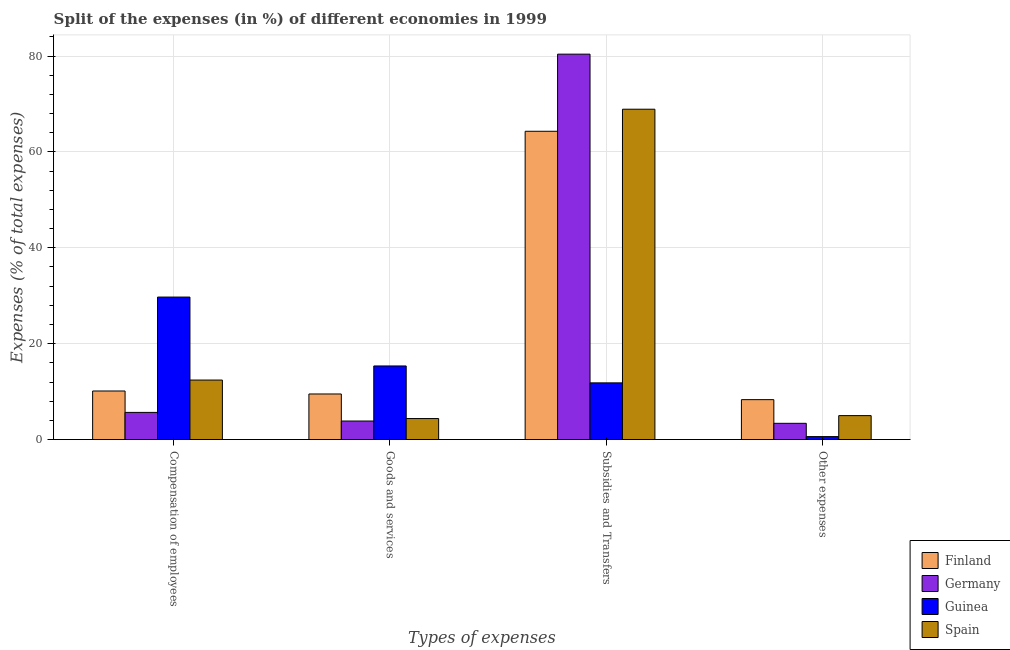Are the number of bars per tick equal to the number of legend labels?
Provide a succinct answer. Yes. Are the number of bars on each tick of the X-axis equal?
Offer a terse response. Yes. What is the label of the 1st group of bars from the left?
Offer a very short reply. Compensation of employees. What is the percentage of amount spent on goods and services in Guinea?
Your response must be concise. 15.36. Across all countries, what is the maximum percentage of amount spent on subsidies?
Provide a short and direct response. 80.39. Across all countries, what is the minimum percentage of amount spent on goods and services?
Ensure brevity in your answer.  3.87. In which country was the percentage of amount spent on goods and services maximum?
Your answer should be very brief. Guinea. What is the total percentage of amount spent on goods and services in the graph?
Provide a succinct answer. 33.14. What is the difference between the percentage of amount spent on other expenses in Guinea and that in Finland?
Ensure brevity in your answer.  -7.71. What is the difference between the percentage of amount spent on goods and services in Finland and the percentage of amount spent on other expenses in Spain?
Provide a succinct answer. 4.51. What is the average percentage of amount spent on subsidies per country?
Keep it short and to the point. 56.36. What is the difference between the percentage of amount spent on compensation of employees and percentage of amount spent on subsidies in Spain?
Ensure brevity in your answer.  -56.49. What is the ratio of the percentage of amount spent on goods and services in Spain to that in Finland?
Your answer should be very brief. 0.46. Is the percentage of amount spent on compensation of employees in Germany less than that in Guinea?
Give a very brief answer. Yes. What is the difference between the highest and the second highest percentage of amount spent on subsidies?
Provide a succinct answer. 11.48. What is the difference between the highest and the lowest percentage of amount spent on compensation of employees?
Your answer should be very brief. 24.05. In how many countries, is the percentage of amount spent on goods and services greater than the average percentage of amount spent on goods and services taken over all countries?
Offer a very short reply. 2. Is it the case that in every country, the sum of the percentage of amount spent on compensation of employees and percentage of amount spent on goods and services is greater than the sum of percentage of amount spent on other expenses and percentage of amount spent on subsidies?
Your answer should be compact. No. What does the 4th bar from the left in Compensation of employees represents?
Your answer should be compact. Spain. What does the 3rd bar from the right in Other expenses represents?
Your response must be concise. Germany. Is it the case that in every country, the sum of the percentage of amount spent on compensation of employees and percentage of amount spent on goods and services is greater than the percentage of amount spent on subsidies?
Your answer should be very brief. No. How many countries are there in the graph?
Provide a short and direct response. 4. What is the difference between two consecutive major ticks on the Y-axis?
Ensure brevity in your answer.  20. Does the graph contain any zero values?
Your answer should be very brief. No. Does the graph contain grids?
Your response must be concise. Yes. What is the title of the graph?
Your answer should be very brief. Split of the expenses (in %) of different economies in 1999. What is the label or title of the X-axis?
Offer a very short reply. Types of expenses. What is the label or title of the Y-axis?
Give a very brief answer. Expenses (% of total expenses). What is the Expenses (% of total expenses) of Finland in Compensation of employees?
Make the answer very short. 10.14. What is the Expenses (% of total expenses) in Germany in Compensation of employees?
Provide a short and direct response. 5.67. What is the Expenses (% of total expenses) in Guinea in Compensation of employees?
Your response must be concise. 29.73. What is the Expenses (% of total expenses) of Spain in Compensation of employees?
Give a very brief answer. 12.42. What is the Expenses (% of total expenses) in Finland in Goods and services?
Make the answer very short. 9.51. What is the Expenses (% of total expenses) in Germany in Goods and services?
Your answer should be compact. 3.87. What is the Expenses (% of total expenses) of Guinea in Goods and services?
Your answer should be compact. 15.36. What is the Expenses (% of total expenses) of Spain in Goods and services?
Make the answer very short. 4.39. What is the Expenses (% of total expenses) in Finland in Subsidies and Transfers?
Your response must be concise. 64.3. What is the Expenses (% of total expenses) in Germany in Subsidies and Transfers?
Offer a terse response. 80.39. What is the Expenses (% of total expenses) in Guinea in Subsidies and Transfers?
Your response must be concise. 11.83. What is the Expenses (% of total expenses) of Spain in Subsidies and Transfers?
Keep it short and to the point. 68.91. What is the Expenses (% of total expenses) in Finland in Other expenses?
Your answer should be compact. 8.33. What is the Expenses (% of total expenses) of Germany in Other expenses?
Your answer should be very brief. 3.4. What is the Expenses (% of total expenses) in Guinea in Other expenses?
Ensure brevity in your answer.  0.63. What is the Expenses (% of total expenses) in Spain in Other expenses?
Make the answer very short. 5. Across all Types of expenses, what is the maximum Expenses (% of total expenses) of Finland?
Your response must be concise. 64.3. Across all Types of expenses, what is the maximum Expenses (% of total expenses) of Germany?
Keep it short and to the point. 80.39. Across all Types of expenses, what is the maximum Expenses (% of total expenses) of Guinea?
Give a very brief answer. 29.73. Across all Types of expenses, what is the maximum Expenses (% of total expenses) of Spain?
Give a very brief answer. 68.91. Across all Types of expenses, what is the minimum Expenses (% of total expenses) of Finland?
Make the answer very short. 8.33. Across all Types of expenses, what is the minimum Expenses (% of total expenses) in Germany?
Your answer should be very brief. 3.4. Across all Types of expenses, what is the minimum Expenses (% of total expenses) in Guinea?
Your answer should be very brief. 0.63. Across all Types of expenses, what is the minimum Expenses (% of total expenses) in Spain?
Provide a succinct answer. 4.39. What is the total Expenses (% of total expenses) of Finland in the graph?
Your answer should be compact. 92.29. What is the total Expenses (% of total expenses) of Germany in the graph?
Provide a succinct answer. 93.33. What is the total Expenses (% of total expenses) in Guinea in the graph?
Provide a succinct answer. 57.54. What is the total Expenses (% of total expenses) of Spain in the graph?
Make the answer very short. 90.72. What is the difference between the Expenses (% of total expenses) of Finland in Compensation of employees and that in Goods and services?
Your response must be concise. 0.62. What is the difference between the Expenses (% of total expenses) of Germany in Compensation of employees and that in Goods and services?
Your response must be concise. 1.8. What is the difference between the Expenses (% of total expenses) of Guinea in Compensation of employees and that in Goods and services?
Keep it short and to the point. 14.37. What is the difference between the Expenses (% of total expenses) of Spain in Compensation of employees and that in Goods and services?
Provide a short and direct response. 8.03. What is the difference between the Expenses (% of total expenses) in Finland in Compensation of employees and that in Subsidies and Transfers?
Give a very brief answer. -54.17. What is the difference between the Expenses (% of total expenses) of Germany in Compensation of employees and that in Subsidies and Transfers?
Your answer should be compact. -74.72. What is the difference between the Expenses (% of total expenses) of Guinea in Compensation of employees and that in Subsidies and Transfers?
Your response must be concise. 17.89. What is the difference between the Expenses (% of total expenses) in Spain in Compensation of employees and that in Subsidies and Transfers?
Provide a short and direct response. -56.49. What is the difference between the Expenses (% of total expenses) in Finland in Compensation of employees and that in Other expenses?
Offer a very short reply. 1.8. What is the difference between the Expenses (% of total expenses) of Germany in Compensation of employees and that in Other expenses?
Provide a succinct answer. 2.28. What is the difference between the Expenses (% of total expenses) in Guinea in Compensation of employees and that in Other expenses?
Offer a very short reply. 29.1. What is the difference between the Expenses (% of total expenses) in Spain in Compensation of employees and that in Other expenses?
Your response must be concise. 7.42. What is the difference between the Expenses (% of total expenses) of Finland in Goods and services and that in Subsidies and Transfers?
Give a very brief answer. -54.79. What is the difference between the Expenses (% of total expenses) in Germany in Goods and services and that in Subsidies and Transfers?
Offer a very short reply. -76.52. What is the difference between the Expenses (% of total expenses) in Guinea in Goods and services and that in Subsidies and Transfers?
Your answer should be compact. 3.53. What is the difference between the Expenses (% of total expenses) of Spain in Goods and services and that in Subsidies and Transfers?
Your answer should be very brief. -64.52. What is the difference between the Expenses (% of total expenses) in Finland in Goods and services and that in Other expenses?
Your answer should be compact. 1.18. What is the difference between the Expenses (% of total expenses) of Germany in Goods and services and that in Other expenses?
Your answer should be very brief. 0.48. What is the difference between the Expenses (% of total expenses) in Guinea in Goods and services and that in Other expenses?
Your answer should be compact. 14.73. What is the difference between the Expenses (% of total expenses) in Spain in Goods and services and that in Other expenses?
Your answer should be compact. -0.61. What is the difference between the Expenses (% of total expenses) in Finland in Subsidies and Transfers and that in Other expenses?
Provide a short and direct response. 55.97. What is the difference between the Expenses (% of total expenses) of Germany in Subsidies and Transfers and that in Other expenses?
Your answer should be very brief. 76.99. What is the difference between the Expenses (% of total expenses) in Guinea in Subsidies and Transfers and that in Other expenses?
Offer a terse response. 11.21. What is the difference between the Expenses (% of total expenses) of Spain in Subsidies and Transfers and that in Other expenses?
Keep it short and to the point. 63.9. What is the difference between the Expenses (% of total expenses) in Finland in Compensation of employees and the Expenses (% of total expenses) in Germany in Goods and services?
Your answer should be very brief. 6.26. What is the difference between the Expenses (% of total expenses) of Finland in Compensation of employees and the Expenses (% of total expenses) of Guinea in Goods and services?
Your answer should be compact. -5.22. What is the difference between the Expenses (% of total expenses) in Finland in Compensation of employees and the Expenses (% of total expenses) in Spain in Goods and services?
Offer a terse response. 5.75. What is the difference between the Expenses (% of total expenses) of Germany in Compensation of employees and the Expenses (% of total expenses) of Guinea in Goods and services?
Your answer should be compact. -9.68. What is the difference between the Expenses (% of total expenses) of Germany in Compensation of employees and the Expenses (% of total expenses) of Spain in Goods and services?
Keep it short and to the point. 1.28. What is the difference between the Expenses (% of total expenses) in Guinea in Compensation of employees and the Expenses (% of total expenses) in Spain in Goods and services?
Your answer should be compact. 25.34. What is the difference between the Expenses (% of total expenses) in Finland in Compensation of employees and the Expenses (% of total expenses) in Germany in Subsidies and Transfers?
Keep it short and to the point. -70.25. What is the difference between the Expenses (% of total expenses) in Finland in Compensation of employees and the Expenses (% of total expenses) in Guinea in Subsidies and Transfers?
Provide a succinct answer. -1.69. What is the difference between the Expenses (% of total expenses) of Finland in Compensation of employees and the Expenses (% of total expenses) of Spain in Subsidies and Transfers?
Make the answer very short. -58.77. What is the difference between the Expenses (% of total expenses) in Germany in Compensation of employees and the Expenses (% of total expenses) in Guinea in Subsidies and Transfers?
Offer a very short reply. -6.16. What is the difference between the Expenses (% of total expenses) in Germany in Compensation of employees and the Expenses (% of total expenses) in Spain in Subsidies and Transfers?
Keep it short and to the point. -63.23. What is the difference between the Expenses (% of total expenses) in Guinea in Compensation of employees and the Expenses (% of total expenses) in Spain in Subsidies and Transfers?
Keep it short and to the point. -39.18. What is the difference between the Expenses (% of total expenses) in Finland in Compensation of employees and the Expenses (% of total expenses) in Germany in Other expenses?
Provide a short and direct response. 6.74. What is the difference between the Expenses (% of total expenses) of Finland in Compensation of employees and the Expenses (% of total expenses) of Guinea in Other expenses?
Your answer should be very brief. 9.51. What is the difference between the Expenses (% of total expenses) in Finland in Compensation of employees and the Expenses (% of total expenses) in Spain in Other expenses?
Give a very brief answer. 5.14. What is the difference between the Expenses (% of total expenses) of Germany in Compensation of employees and the Expenses (% of total expenses) of Guinea in Other expenses?
Provide a succinct answer. 5.05. What is the difference between the Expenses (% of total expenses) in Germany in Compensation of employees and the Expenses (% of total expenses) in Spain in Other expenses?
Your response must be concise. 0.67. What is the difference between the Expenses (% of total expenses) of Guinea in Compensation of employees and the Expenses (% of total expenses) of Spain in Other expenses?
Offer a very short reply. 24.73. What is the difference between the Expenses (% of total expenses) of Finland in Goods and services and the Expenses (% of total expenses) of Germany in Subsidies and Transfers?
Ensure brevity in your answer.  -70.87. What is the difference between the Expenses (% of total expenses) of Finland in Goods and services and the Expenses (% of total expenses) of Guinea in Subsidies and Transfers?
Keep it short and to the point. -2.32. What is the difference between the Expenses (% of total expenses) in Finland in Goods and services and the Expenses (% of total expenses) in Spain in Subsidies and Transfers?
Offer a terse response. -59.39. What is the difference between the Expenses (% of total expenses) of Germany in Goods and services and the Expenses (% of total expenses) of Guinea in Subsidies and Transfers?
Your response must be concise. -7.96. What is the difference between the Expenses (% of total expenses) in Germany in Goods and services and the Expenses (% of total expenses) in Spain in Subsidies and Transfers?
Your answer should be compact. -65.03. What is the difference between the Expenses (% of total expenses) in Guinea in Goods and services and the Expenses (% of total expenses) in Spain in Subsidies and Transfers?
Provide a short and direct response. -53.55. What is the difference between the Expenses (% of total expenses) in Finland in Goods and services and the Expenses (% of total expenses) in Germany in Other expenses?
Your answer should be very brief. 6.12. What is the difference between the Expenses (% of total expenses) of Finland in Goods and services and the Expenses (% of total expenses) of Guinea in Other expenses?
Offer a very short reply. 8.89. What is the difference between the Expenses (% of total expenses) in Finland in Goods and services and the Expenses (% of total expenses) in Spain in Other expenses?
Make the answer very short. 4.51. What is the difference between the Expenses (% of total expenses) of Germany in Goods and services and the Expenses (% of total expenses) of Guinea in Other expenses?
Provide a succinct answer. 3.25. What is the difference between the Expenses (% of total expenses) in Germany in Goods and services and the Expenses (% of total expenses) in Spain in Other expenses?
Your answer should be very brief. -1.13. What is the difference between the Expenses (% of total expenses) of Guinea in Goods and services and the Expenses (% of total expenses) of Spain in Other expenses?
Make the answer very short. 10.36. What is the difference between the Expenses (% of total expenses) of Finland in Subsidies and Transfers and the Expenses (% of total expenses) of Germany in Other expenses?
Offer a terse response. 60.91. What is the difference between the Expenses (% of total expenses) of Finland in Subsidies and Transfers and the Expenses (% of total expenses) of Guinea in Other expenses?
Your answer should be very brief. 63.68. What is the difference between the Expenses (% of total expenses) of Finland in Subsidies and Transfers and the Expenses (% of total expenses) of Spain in Other expenses?
Your answer should be very brief. 59.3. What is the difference between the Expenses (% of total expenses) of Germany in Subsidies and Transfers and the Expenses (% of total expenses) of Guinea in Other expenses?
Your response must be concise. 79.76. What is the difference between the Expenses (% of total expenses) of Germany in Subsidies and Transfers and the Expenses (% of total expenses) of Spain in Other expenses?
Provide a short and direct response. 75.39. What is the difference between the Expenses (% of total expenses) in Guinea in Subsidies and Transfers and the Expenses (% of total expenses) in Spain in Other expenses?
Keep it short and to the point. 6.83. What is the average Expenses (% of total expenses) in Finland per Types of expenses?
Your answer should be very brief. 23.07. What is the average Expenses (% of total expenses) in Germany per Types of expenses?
Give a very brief answer. 23.33. What is the average Expenses (% of total expenses) in Guinea per Types of expenses?
Your answer should be very brief. 14.39. What is the average Expenses (% of total expenses) in Spain per Types of expenses?
Keep it short and to the point. 22.68. What is the difference between the Expenses (% of total expenses) of Finland and Expenses (% of total expenses) of Germany in Compensation of employees?
Your answer should be very brief. 4.47. What is the difference between the Expenses (% of total expenses) of Finland and Expenses (% of total expenses) of Guinea in Compensation of employees?
Offer a very short reply. -19.59. What is the difference between the Expenses (% of total expenses) in Finland and Expenses (% of total expenses) in Spain in Compensation of employees?
Your answer should be very brief. -2.28. What is the difference between the Expenses (% of total expenses) of Germany and Expenses (% of total expenses) of Guinea in Compensation of employees?
Ensure brevity in your answer.  -24.05. What is the difference between the Expenses (% of total expenses) in Germany and Expenses (% of total expenses) in Spain in Compensation of employees?
Provide a succinct answer. -6.75. What is the difference between the Expenses (% of total expenses) in Guinea and Expenses (% of total expenses) in Spain in Compensation of employees?
Offer a terse response. 17.31. What is the difference between the Expenses (% of total expenses) of Finland and Expenses (% of total expenses) of Germany in Goods and services?
Your answer should be compact. 5.64. What is the difference between the Expenses (% of total expenses) of Finland and Expenses (% of total expenses) of Guinea in Goods and services?
Your answer should be very brief. -5.84. What is the difference between the Expenses (% of total expenses) in Finland and Expenses (% of total expenses) in Spain in Goods and services?
Make the answer very short. 5.12. What is the difference between the Expenses (% of total expenses) of Germany and Expenses (% of total expenses) of Guinea in Goods and services?
Give a very brief answer. -11.48. What is the difference between the Expenses (% of total expenses) in Germany and Expenses (% of total expenses) in Spain in Goods and services?
Your answer should be compact. -0.52. What is the difference between the Expenses (% of total expenses) in Guinea and Expenses (% of total expenses) in Spain in Goods and services?
Your response must be concise. 10.97. What is the difference between the Expenses (% of total expenses) in Finland and Expenses (% of total expenses) in Germany in Subsidies and Transfers?
Your answer should be very brief. -16.08. What is the difference between the Expenses (% of total expenses) of Finland and Expenses (% of total expenses) of Guinea in Subsidies and Transfers?
Provide a succinct answer. 52.47. What is the difference between the Expenses (% of total expenses) of Finland and Expenses (% of total expenses) of Spain in Subsidies and Transfers?
Your response must be concise. -4.6. What is the difference between the Expenses (% of total expenses) in Germany and Expenses (% of total expenses) in Guinea in Subsidies and Transfers?
Offer a very short reply. 68.56. What is the difference between the Expenses (% of total expenses) in Germany and Expenses (% of total expenses) in Spain in Subsidies and Transfers?
Your response must be concise. 11.48. What is the difference between the Expenses (% of total expenses) in Guinea and Expenses (% of total expenses) in Spain in Subsidies and Transfers?
Keep it short and to the point. -57.07. What is the difference between the Expenses (% of total expenses) of Finland and Expenses (% of total expenses) of Germany in Other expenses?
Your answer should be compact. 4.94. What is the difference between the Expenses (% of total expenses) of Finland and Expenses (% of total expenses) of Guinea in Other expenses?
Your answer should be very brief. 7.71. What is the difference between the Expenses (% of total expenses) of Finland and Expenses (% of total expenses) of Spain in Other expenses?
Offer a terse response. 3.33. What is the difference between the Expenses (% of total expenses) of Germany and Expenses (% of total expenses) of Guinea in Other expenses?
Provide a short and direct response. 2.77. What is the difference between the Expenses (% of total expenses) in Germany and Expenses (% of total expenses) in Spain in Other expenses?
Offer a terse response. -1.6. What is the difference between the Expenses (% of total expenses) in Guinea and Expenses (% of total expenses) in Spain in Other expenses?
Offer a terse response. -4.38. What is the ratio of the Expenses (% of total expenses) in Finland in Compensation of employees to that in Goods and services?
Keep it short and to the point. 1.07. What is the ratio of the Expenses (% of total expenses) in Germany in Compensation of employees to that in Goods and services?
Your answer should be very brief. 1.46. What is the ratio of the Expenses (% of total expenses) in Guinea in Compensation of employees to that in Goods and services?
Provide a short and direct response. 1.94. What is the ratio of the Expenses (% of total expenses) of Spain in Compensation of employees to that in Goods and services?
Make the answer very short. 2.83. What is the ratio of the Expenses (% of total expenses) of Finland in Compensation of employees to that in Subsidies and Transfers?
Offer a terse response. 0.16. What is the ratio of the Expenses (% of total expenses) of Germany in Compensation of employees to that in Subsidies and Transfers?
Make the answer very short. 0.07. What is the ratio of the Expenses (% of total expenses) in Guinea in Compensation of employees to that in Subsidies and Transfers?
Offer a terse response. 2.51. What is the ratio of the Expenses (% of total expenses) of Spain in Compensation of employees to that in Subsidies and Transfers?
Keep it short and to the point. 0.18. What is the ratio of the Expenses (% of total expenses) of Finland in Compensation of employees to that in Other expenses?
Offer a terse response. 1.22. What is the ratio of the Expenses (% of total expenses) in Germany in Compensation of employees to that in Other expenses?
Your response must be concise. 1.67. What is the ratio of the Expenses (% of total expenses) in Guinea in Compensation of employees to that in Other expenses?
Make the answer very short. 47.46. What is the ratio of the Expenses (% of total expenses) of Spain in Compensation of employees to that in Other expenses?
Offer a very short reply. 2.48. What is the ratio of the Expenses (% of total expenses) of Finland in Goods and services to that in Subsidies and Transfers?
Give a very brief answer. 0.15. What is the ratio of the Expenses (% of total expenses) of Germany in Goods and services to that in Subsidies and Transfers?
Your answer should be very brief. 0.05. What is the ratio of the Expenses (% of total expenses) in Guinea in Goods and services to that in Subsidies and Transfers?
Ensure brevity in your answer.  1.3. What is the ratio of the Expenses (% of total expenses) of Spain in Goods and services to that in Subsidies and Transfers?
Offer a terse response. 0.06. What is the ratio of the Expenses (% of total expenses) of Finland in Goods and services to that in Other expenses?
Your answer should be compact. 1.14. What is the ratio of the Expenses (% of total expenses) of Germany in Goods and services to that in Other expenses?
Give a very brief answer. 1.14. What is the ratio of the Expenses (% of total expenses) of Guinea in Goods and services to that in Other expenses?
Ensure brevity in your answer.  24.52. What is the ratio of the Expenses (% of total expenses) of Spain in Goods and services to that in Other expenses?
Give a very brief answer. 0.88. What is the ratio of the Expenses (% of total expenses) of Finland in Subsidies and Transfers to that in Other expenses?
Provide a short and direct response. 7.72. What is the ratio of the Expenses (% of total expenses) in Germany in Subsidies and Transfers to that in Other expenses?
Give a very brief answer. 23.66. What is the ratio of the Expenses (% of total expenses) in Guinea in Subsidies and Transfers to that in Other expenses?
Give a very brief answer. 18.89. What is the ratio of the Expenses (% of total expenses) of Spain in Subsidies and Transfers to that in Other expenses?
Offer a very short reply. 13.78. What is the difference between the highest and the second highest Expenses (% of total expenses) in Finland?
Give a very brief answer. 54.17. What is the difference between the highest and the second highest Expenses (% of total expenses) of Germany?
Give a very brief answer. 74.72. What is the difference between the highest and the second highest Expenses (% of total expenses) in Guinea?
Give a very brief answer. 14.37. What is the difference between the highest and the second highest Expenses (% of total expenses) in Spain?
Keep it short and to the point. 56.49. What is the difference between the highest and the lowest Expenses (% of total expenses) of Finland?
Your response must be concise. 55.97. What is the difference between the highest and the lowest Expenses (% of total expenses) in Germany?
Keep it short and to the point. 76.99. What is the difference between the highest and the lowest Expenses (% of total expenses) of Guinea?
Ensure brevity in your answer.  29.1. What is the difference between the highest and the lowest Expenses (% of total expenses) in Spain?
Give a very brief answer. 64.52. 